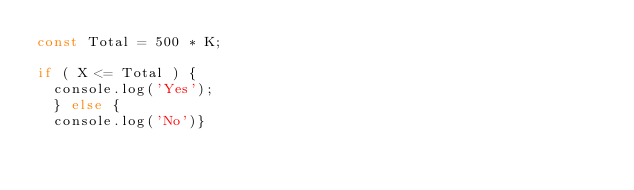Convert code to text. <code><loc_0><loc_0><loc_500><loc_500><_JavaScript_>const Total = 500 * K;

if ( X <= Total ) {
	console.log('Yes');
	} else {
	console.log('No')}  </code> 